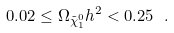Convert formula to latex. <formula><loc_0><loc_0><loc_500><loc_500>0 . 0 2 \leq \Omega _ { \tilde { \chi } _ { 1 } ^ { 0 } } h ^ { 2 } < 0 . 2 5 \ .</formula> 